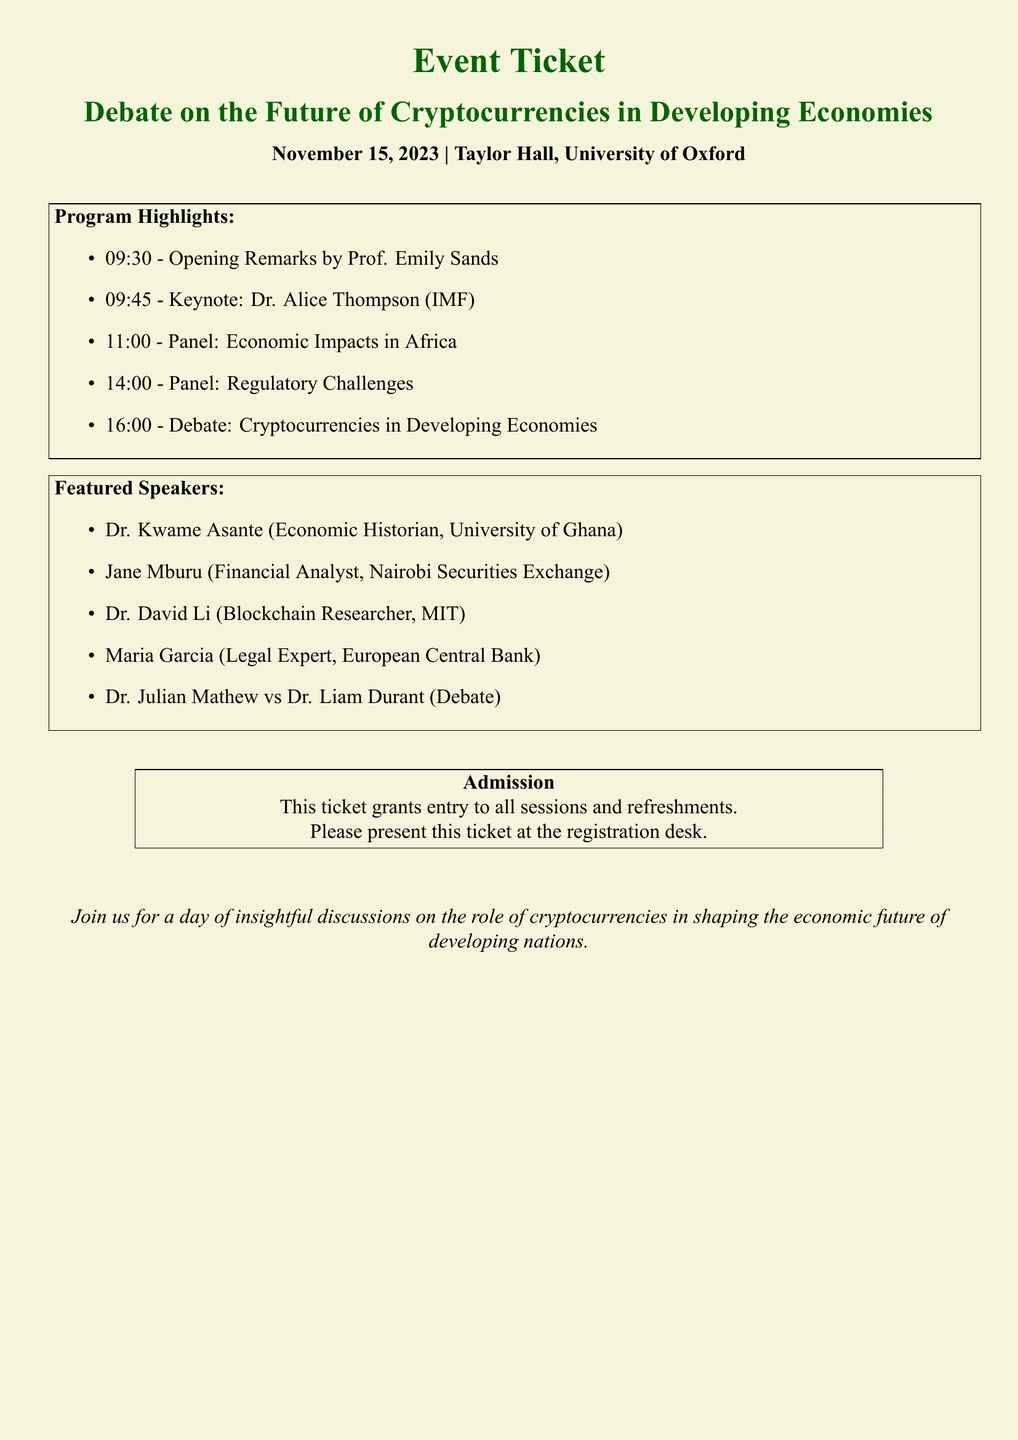What is the date of the event? The date of the event is specified in the document as November 15, 2023.
Answer: November 15, 2023 Who is delivering the keynote speech? The document states that the keynote address will be delivered by Dr. Alice Thompson, who is associated with the IMF.
Answer: Dr. Alice Thompson What topic is covered in the panel at 11:00? The document mentions that the panel at 11:00 will focus on Economic Impacts in Africa.
Answer: Economic Impacts in Africa How many featured speakers are listed? The document lists five featured speakers participating in the event.
Answer: Five What time does the debate on cryptocurrencies start? According to the program, the debate is scheduled to start at 16:00.
Answer: 16:00 Who are the debaters listed at the end of the event? The document specifies that Dr. Julian Mathew will debate Dr. Liam Durant.
Answer: Dr. Julian Mathew vs Dr. Liam Durant Where is the event being held? The venue for the event is clearly indicated as Taylor Hall, University of Oxford.
Answer: Taylor Hall, University of Oxford What does the ticket grant entry to? The ticket grants entry to all sessions and refreshments as stated in the admission section of the document.
Answer: All sessions and refreshments What is the purpose of the event as stated in the document? The document indicates that the event aims to discuss the role of cryptocurrencies in shaping the economic future of developing nations.
Answer: Role of cryptocurrencies in developing nations 